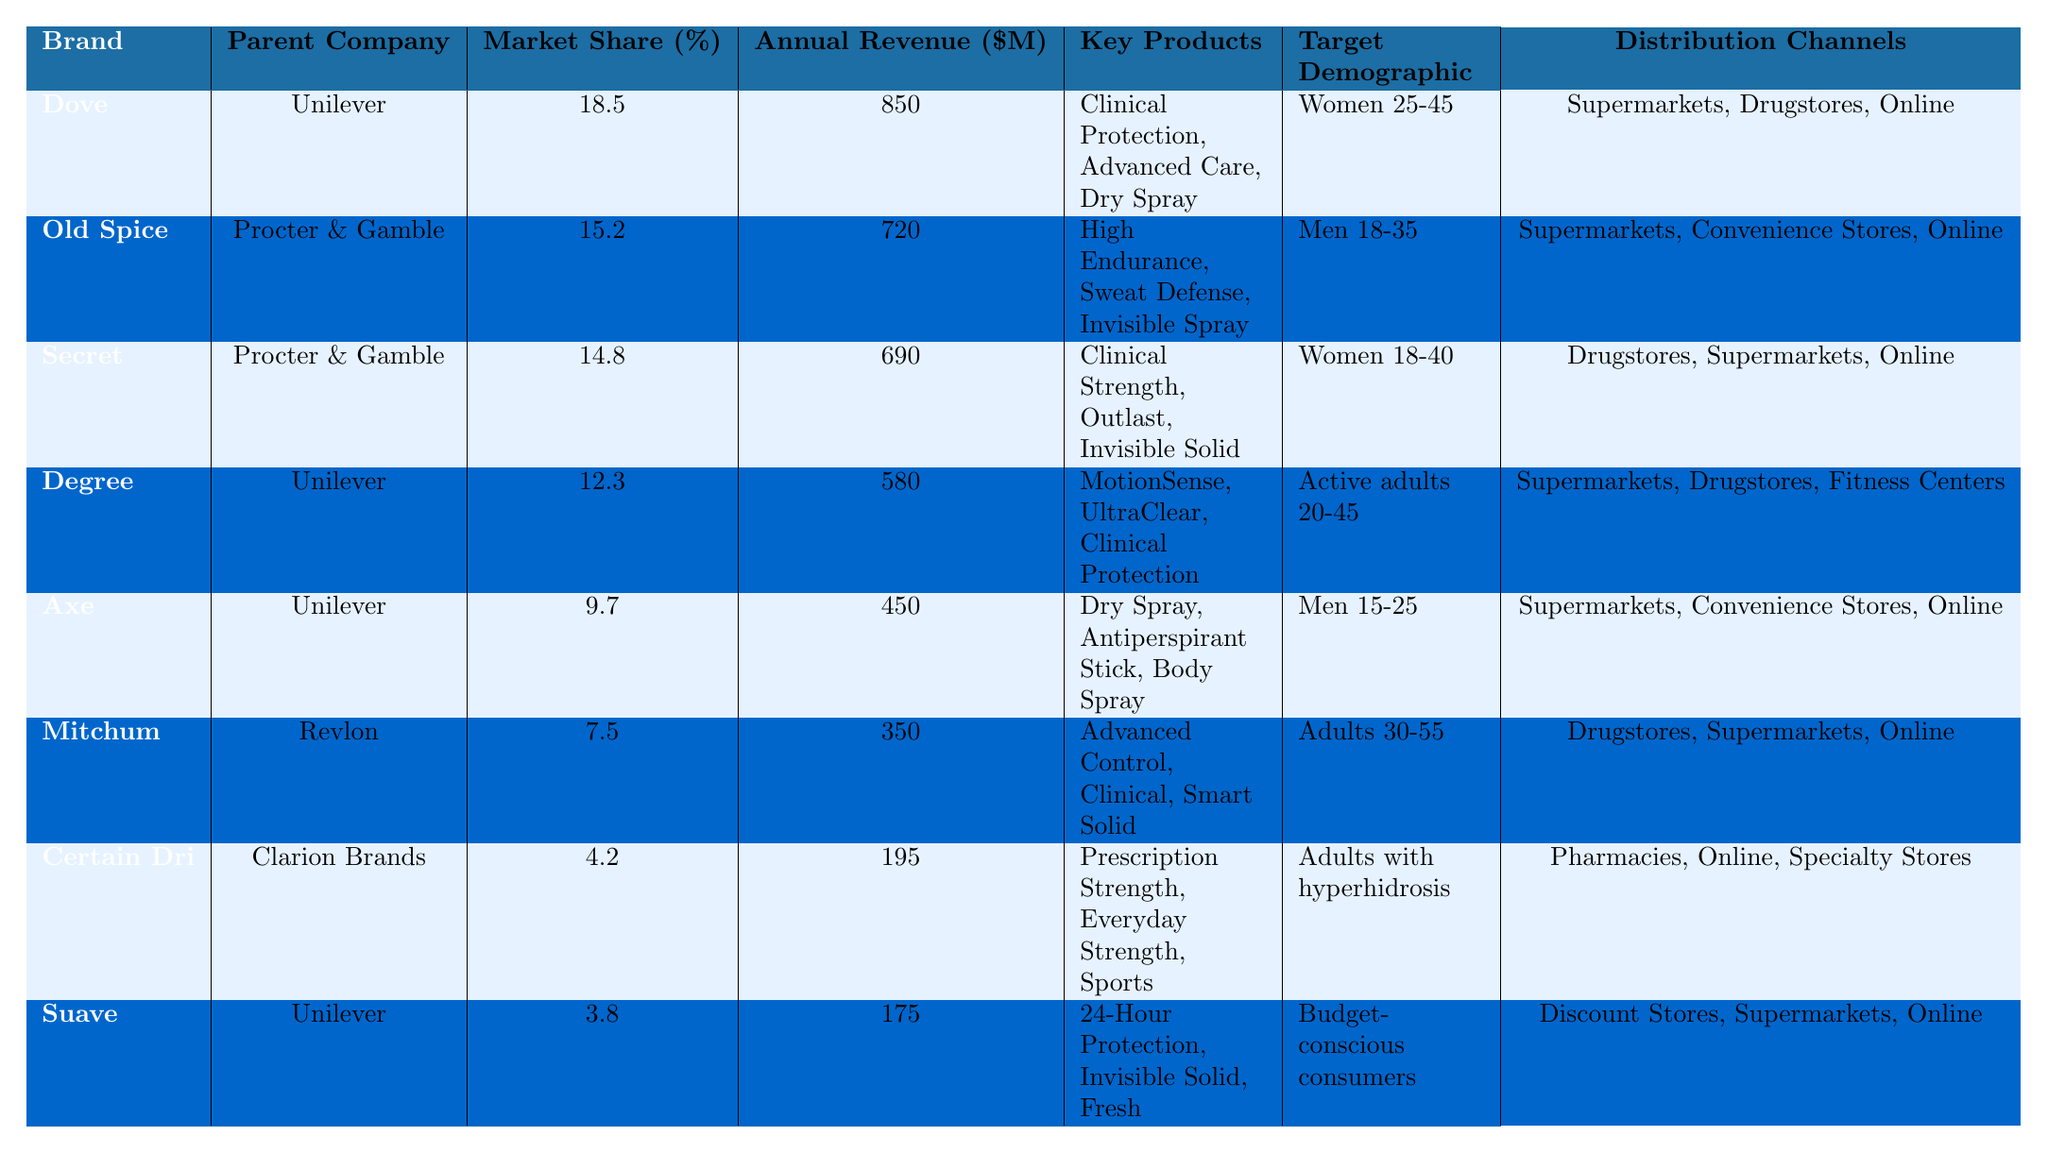What is the market share of Dove? The market share of Dove can be found directly in the table under the "Market Share (%)" column corresponding to Dove, which is 18.5%
Answer: 18.5% Which brand has the highest annual revenue? By comparing the "Annual Revenue ($M)" column for each brand, Dove has the highest revenue at $850 million
Answer: Dove How much market share do Old Spice and Secret have combined? Summing Old Spice's market share (15.2%) and Secret's market share (14.8%) gives a total of 15.2 + 14.8 = 30.0%
Answer: 30.0% Is Axe marketed towards women? Examining the "Target Demographic" column, Axe is targeted towards "Men 15-25", so it is not marketed towards women
Answer: No What is the total annual revenue of all the brands listed? By summing all annual revenues: 850 + 720 + 690 + 580 + 450 + 350 + 195 + 175 = 3510 million
Answer: 3510 million Which parent company has the most brands listed in the table? Counting the brands by their parent companies: Unilever has 4 brands (Dove, Degree, Axe, Suave) and Procter & Gamble has 2 (Old Spice, Secret). Revlon has 1 (Mitchum), and Clarion Brands has 1 (Certain Dri). Therefore, Unilever has the most brands listed
Answer: Unilever What proportion of the market share does Degree hold compared to the total market share of the brands listed? First, calculate the total market share: 18.5 + 15.2 + 14.8 + 12.3 + 9.7 + 7.5 + 4.2 + 3.8 = 86.0%. Then, Degree's market share of 12.3% can be expressed as a proportion of the total: (12.3 / 86.0) * 100 = 14.3%
Answer: 14.3% Do all the brands use online distribution channels? Checking the "Distribution Channels" column shows that all brands, including Certain Dri and Suave, list "Online" as one of their channels. Thus, all brands utilize online distribution
Answer: Yes What is the average market share of the brands owned by Unilever? Unilever owns Dove, Degree, and Axe. Their respective market shares are 18.5, 12.3, and 9.7. The total is 18.5 + 12.3 + 9.7 = 40.5. Dividing by 3 gives an average: 40.5 / 3 = 13.5%
Answer: 13.5% Which brand targets adults with hyperhidrosis? The "Target Demographic" under Certain Dri is "Adults with hyperhidrosis," indicating that this brand specifically targets that demographic
Answer: Certain Dri 